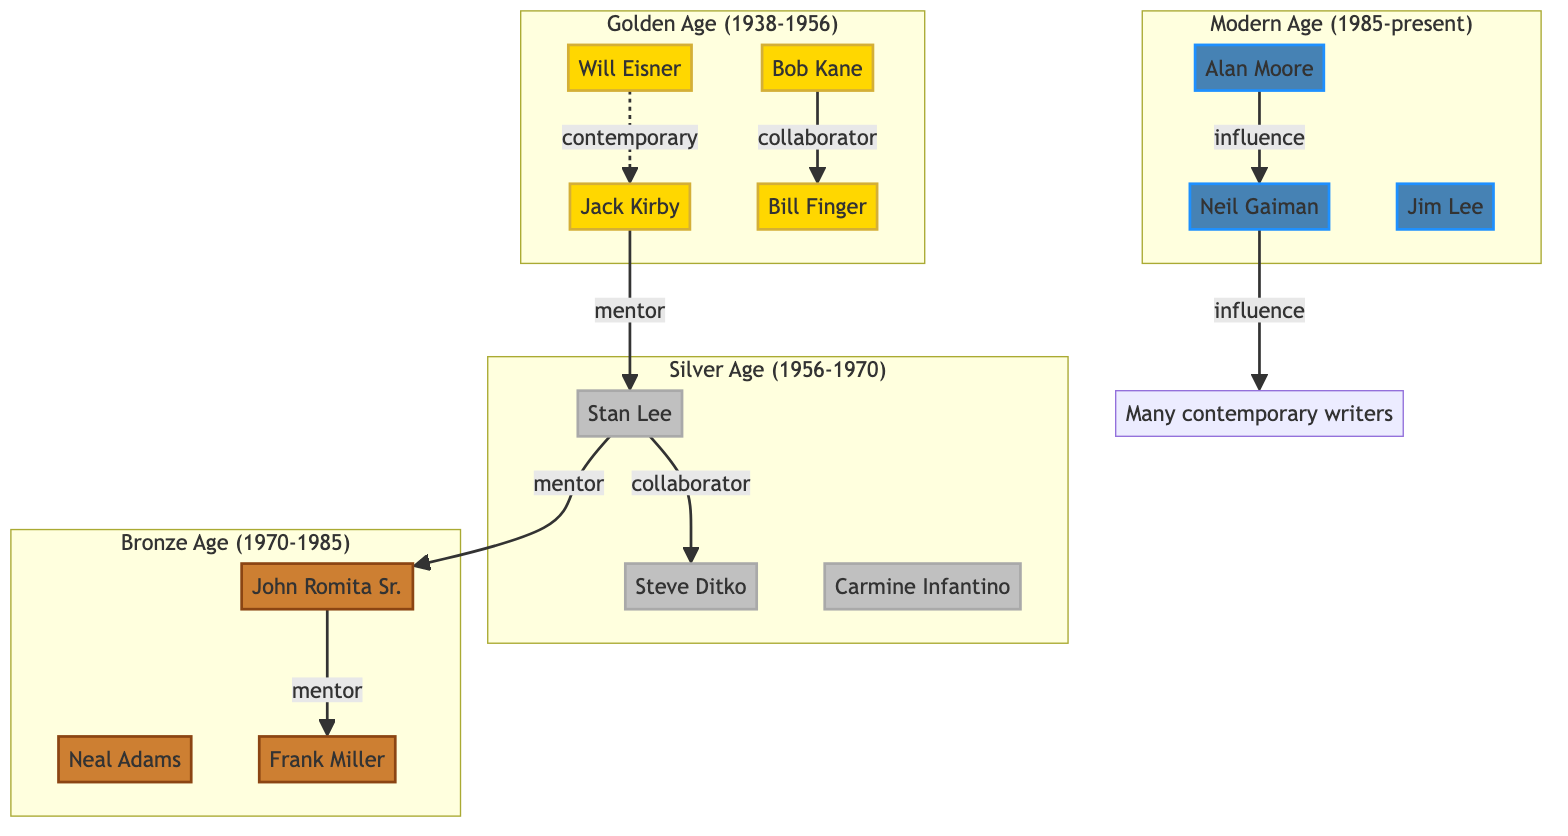What is the period of the Silver Age? The diagram specifies that the Silver Age spans from 1956 to 1970, indicating the timeframe during which the artists listed in that section worked.
Answer: 1956-1970 Who collaborated with Bob Kane? The diagram shows that Bob Kane has a collaboration relationship with Bill Finger, indicating that they worked together on projects like Batman.
Answer: Bill Finger Who is the mentor of John Romita Sr.? According to the diagram, John Romita Sr. is a mentee of Stan Lee, which establishes the mentor-mentee relationship between them.
Answer: Stan Lee How many artists are in the Modern Age section? The diagram displays three artists under the Modern Age section, which can be directly counted by looking at the nodes representing each artist in that section.
Answer: 3 Which artist is influenced by Alan Moore? The diagram indicates that Neil Gaiman is influenced by Alan Moore, establishing a one-way influence relationship.
Answer: Neil Gaiman What was the relationship between Will Eisner and Jack Kirby? The diagram states that Will Eisner was a contemporary of Jack Kirby, indicating that they were from the same era but did not have a direct mentor-mentee or collaborative relationship.
Answer: contemporary Which artist has the most connections in the Golden Age? Analyzing the connections in the Golden Age section, Jack Kirby has one mentor relationship (with Stan Lee) and connections showing him as a contemporary to Will Eisner, thus emphasizing his influence in that era.
Answer: Jack Kirby What is the influence relationship in the Modern Age? The diagram shows that Alan Moore influences Neil Gaiman, and Neil Gaiman influences many contemporary writers, highlighting a cascading influence pattern.
Answer: Alan Moore How many total collaborators are mentioned in the Silver Age? Looking at the Silver Age section, only one collaboration relationship is mentioned between Stan Lee and Steve Ditko, showing their joint involvement in creating comic book works.
Answer: 1 